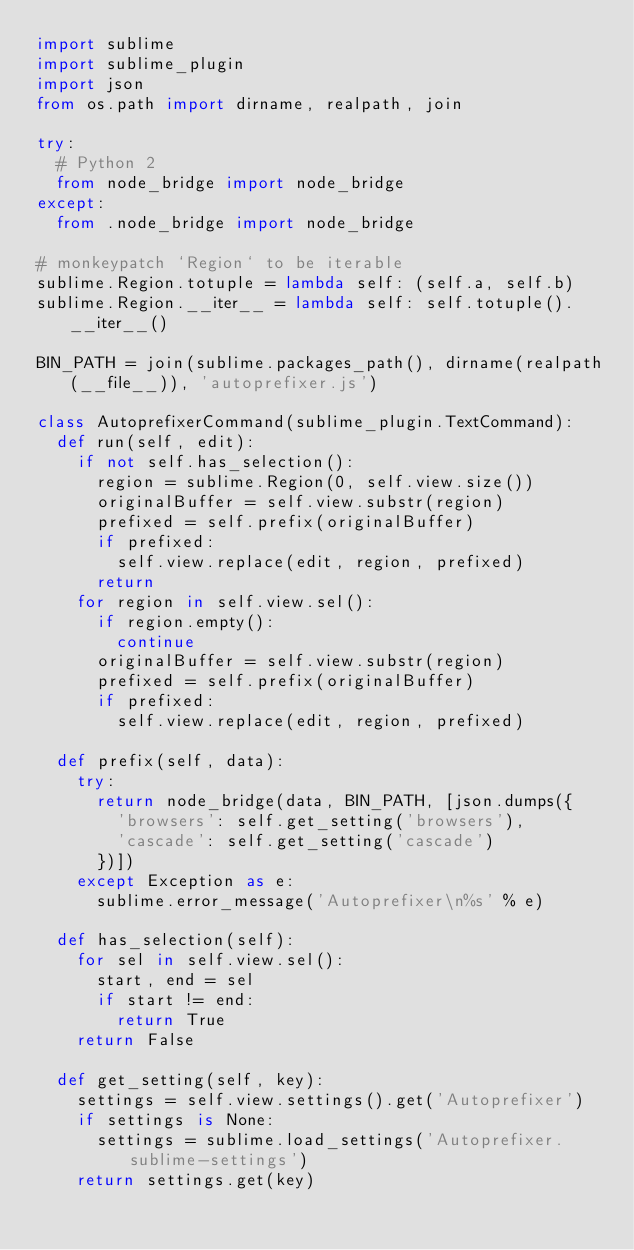<code> <loc_0><loc_0><loc_500><loc_500><_Python_>import sublime
import sublime_plugin
import json
from os.path import dirname, realpath, join

try:
	# Python 2
	from node_bridge import node_bridge
except:
	from .node_bridge import node_bridge

# monkeypatch `Region` to be iterable
sublime.Region.totuple = lambda self: (self.a, self.b)
sublime.Region.__iter__ = lambda self: self.totuple().__iter__()

BIN_PATH = join(sublime.packages_path(), dirname(realpath(__file__)), 'autoprefixer.js')

class AutoprefixerCommand(sublime_plugin.TextCommand):
	def run(self, edit):
		if not self.has_selection():
			region = sublime.Region(0, self.view.size())
			originalBuffer = self.view.substr(region)
			prefixed = self.prefix(originalBuffer)
			if prefixed:
				self.view.replace(edit, region, prefixed)
			return
		for region in self.view.sel():
			if region.empty():
				continue
			originalBuffer = self.view.substr(region)
			prefixed = self.prefix(originalBuffer)
			if prefixed:
				self.view.replace(edit, region, prefixed)

	def prefix(self, data):
		try:
			return node_bridge(data, BIN_PATH, [json.dumps({
				'browsers': self.get_setting('browsers'),
				'cascade': self.get_setting('cascade')
			})])
		except Exception as e:
			sublime.error_message('Autoprefixer\n%s' % e)

	def has_selection(self):
		for sel in self.view.sel():
			start, end = sel
			if start != end:
				return True
		return False

	def get_setting(self, key):
		settings = self.view.settings().get('Autoprefixer')
		if settings is None:
			settings = sublime.load_settings('Autoprefixer.sublime-settings')
		return settings.get(key)
</code> 